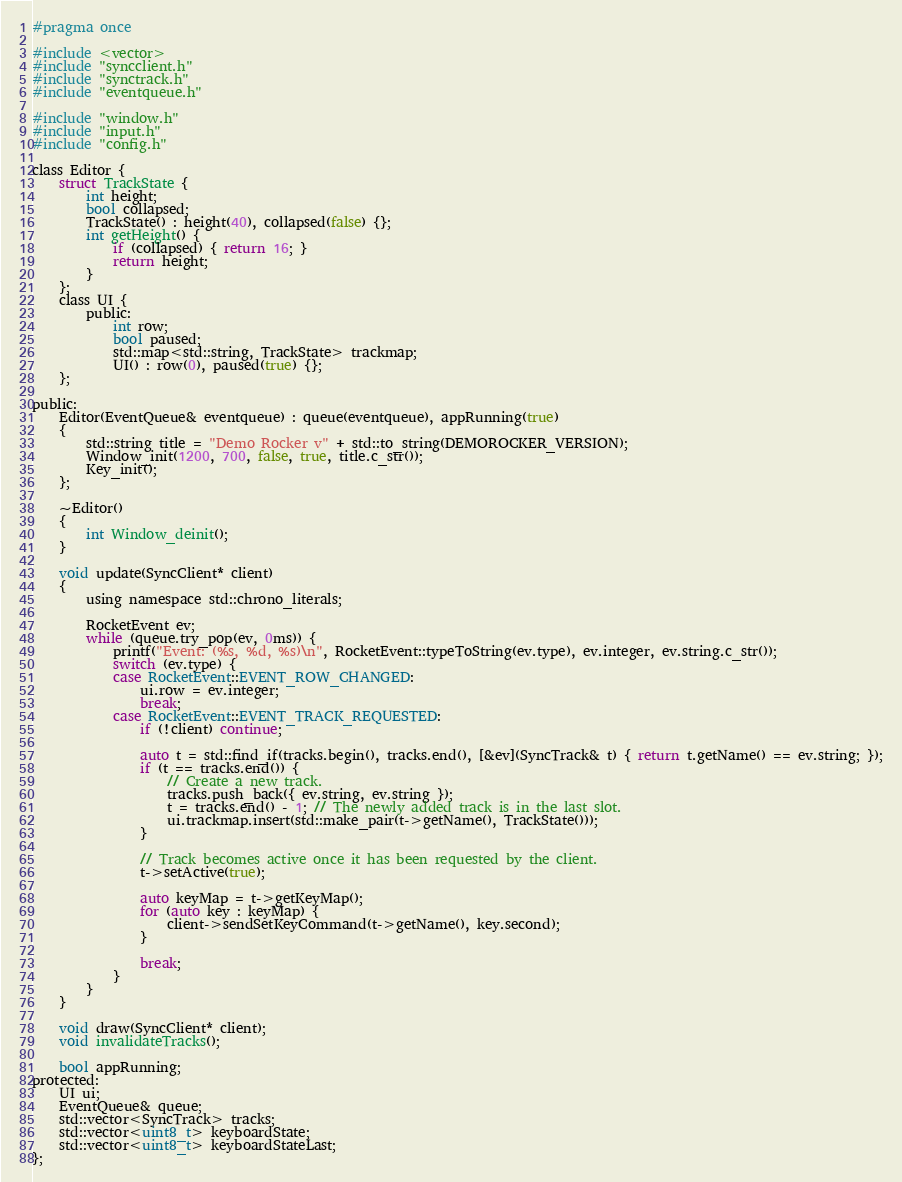<code> <loc_0><loc_0><loc_500><loc_500><_C_>#pragma once

#include <vector>
#include "syncclient.h"
#include "synctrack.h"
#include "eventqueue.h"

#include "window.h"
#include "input.h"
#include "config.h"

class Editor {
	struct TrackState {
		int height;
		bool collapsed;
		TrackState() : height(40), collapsed(false) {};
		int getHeight() {
			if (collapsed) { return 16; }
			return height;
		}
	};
	class UI {
		public:
			int row;
			bool paused;
			std::map<std::string, TrackState> trackmap;
			UI() : row(0), paused(true) {};
	};

public:
	Editor(EventQueue& eventqueue) : queue(eventqueue), appRunning(true)
	{
		std::string title = "Demo Rocker v" + std::to_string(DEMOROCKER_VERSION);
		Window_init(1200, 700, false, true, title.c_str());
		Key_init();
	};

	~Editor()
	{
		int Window_deinit();
	}

	void update(SyncClient* client)
	{
		using namespace std::chrono_literals;

		RocketEvent ev;
		while (queue.try_pop(ev, 0ms)) {
			printf("Event: (%s, %d, %s)\n", RocketEvent::typeToString(ev.type), ev.integer, ev.string.c_str());
			switch (ev.type) {
			case RocketEvent::EVENT_ROW_CHANGED:
				ui.row = ev.integer;
				break;
			case RocketEvent::EVENT_TRACK_REQUESTED:
				if (!client) continue;

				auto t = std::find_if(tracks.begin(), tracks.end(), [&ev](SyncTrack& t) { return t.getName() == ev.string; });
				if (t == tracks.end()) {
					// Create a new track.
					tracks.push_back({ ev.string, ev.string });
					t = tracks.end() - 1; // The newly added track is in the last slot.
					ui.trackmap.insert(std::make_pair(t->getName(), TrackState()));
				}

				// Track becomes active once it has been requested by the client.
				t->setActive(true);

				auto keyMap = t->getKeyMap();
				for (auto key : keyMap) {
					client->sendSetKeyCommand(t->getName(), key.second);
				}

				break;
			}
		}
	}

	void draw(SyncClient* client);
	void invalidateTracks();

	bool appRunning;
protected:
	UI ui;
	EventQueue& queue;
	std::vector<SyncTrack> tracks;
	std::vector<uint8_t> keyboardState;
	std::vector<uint8_t> keyboardStateLast;
};
</code> 